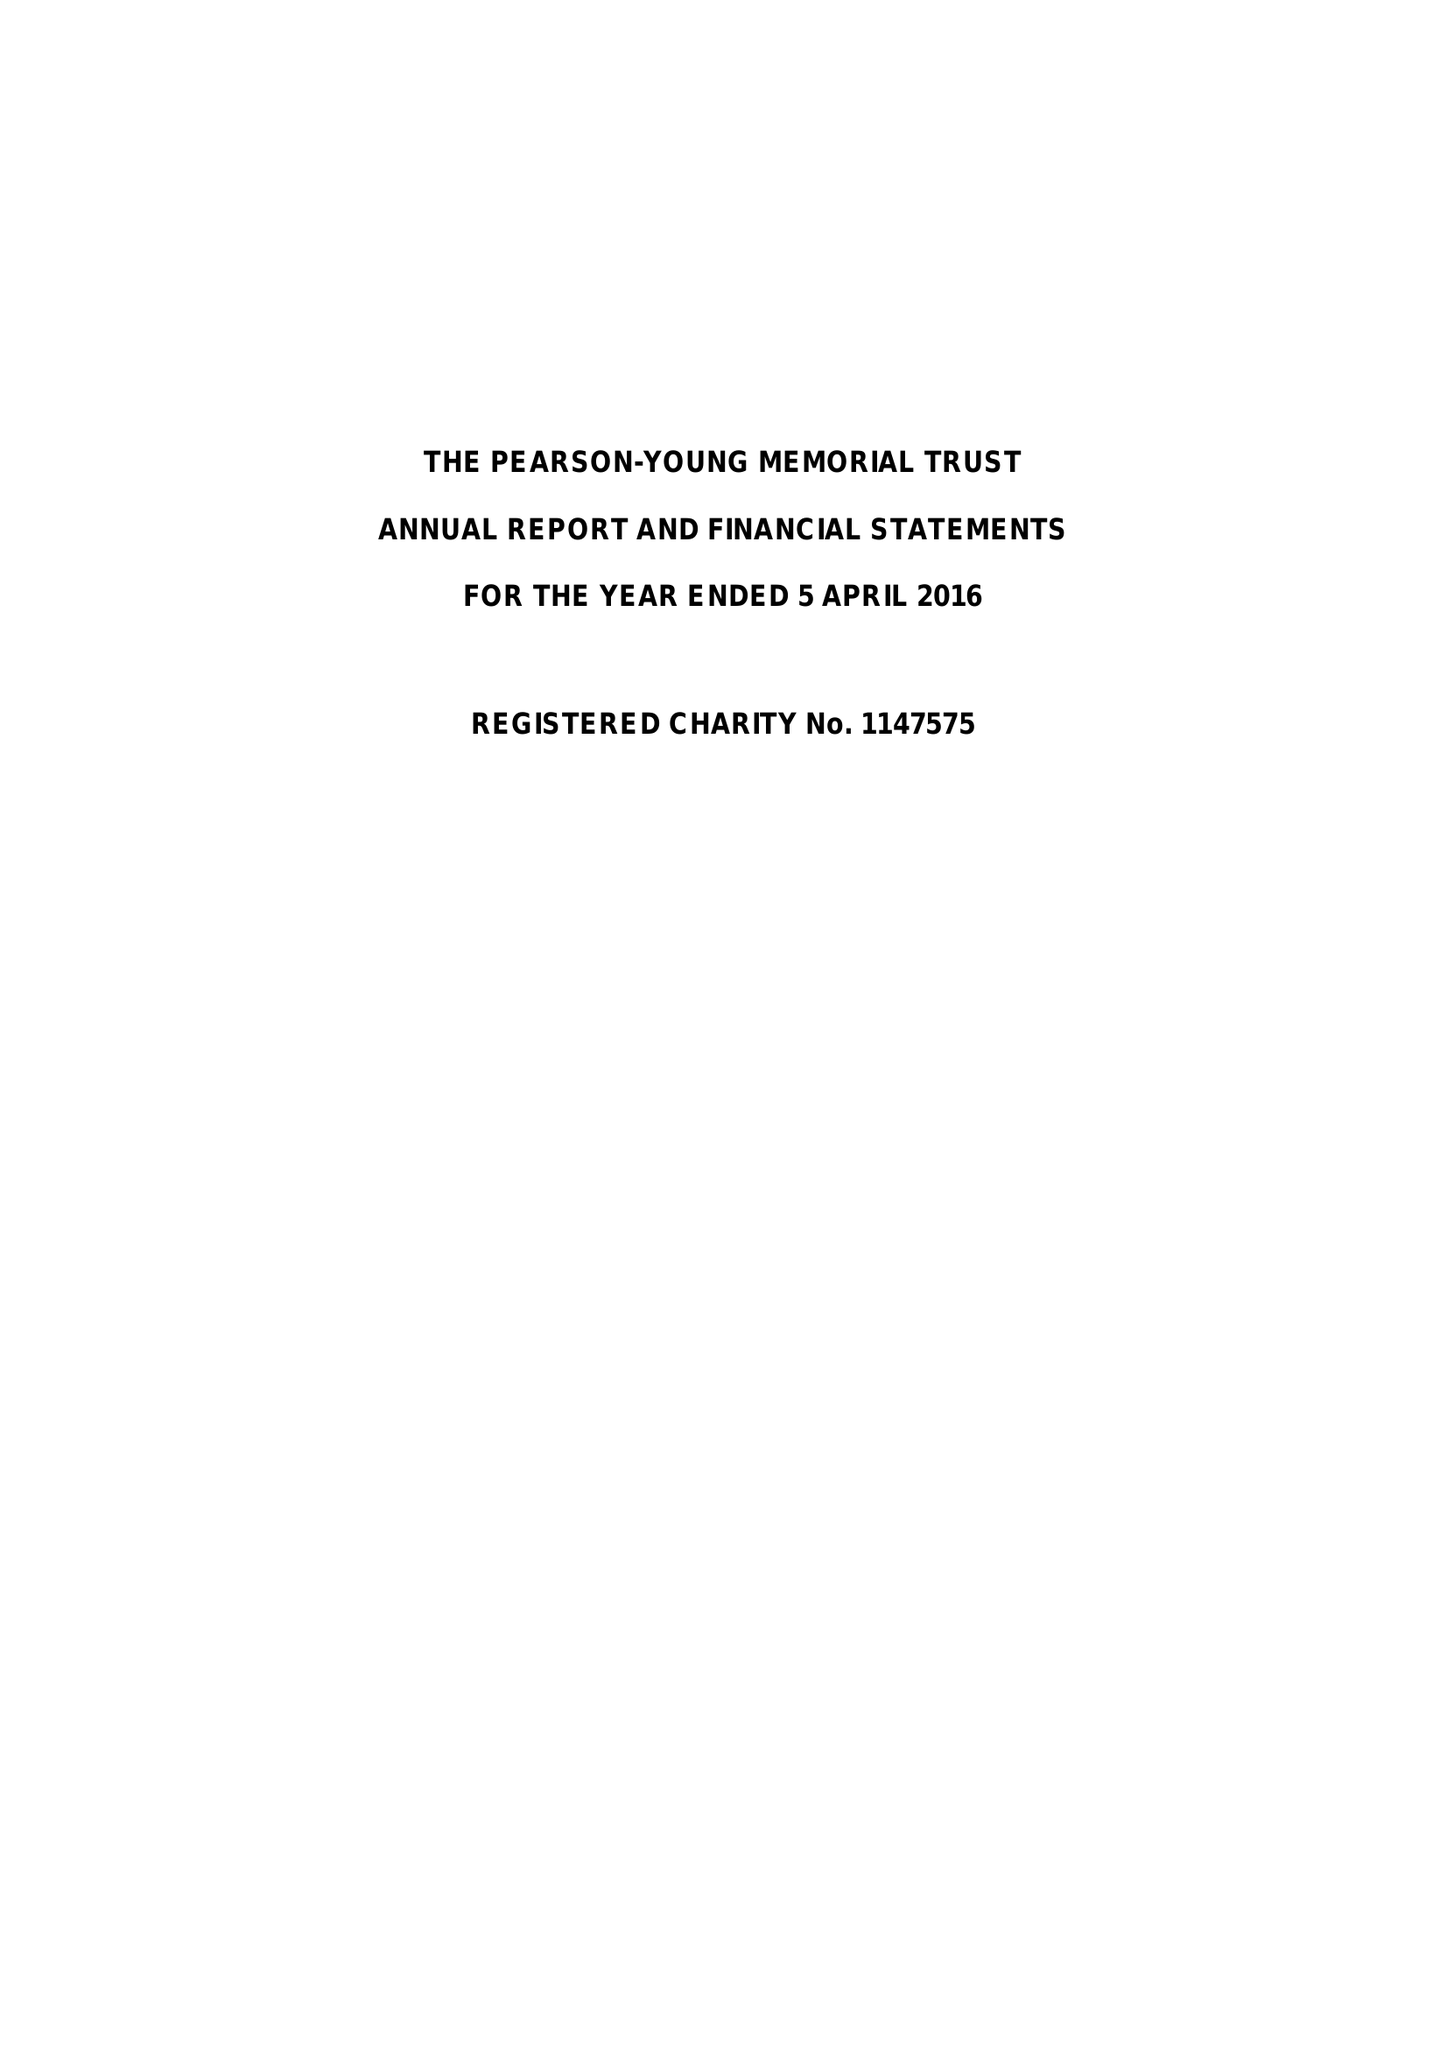What is the value for the address__post_town?
Answer the question using a single word or phrase. LONDON 